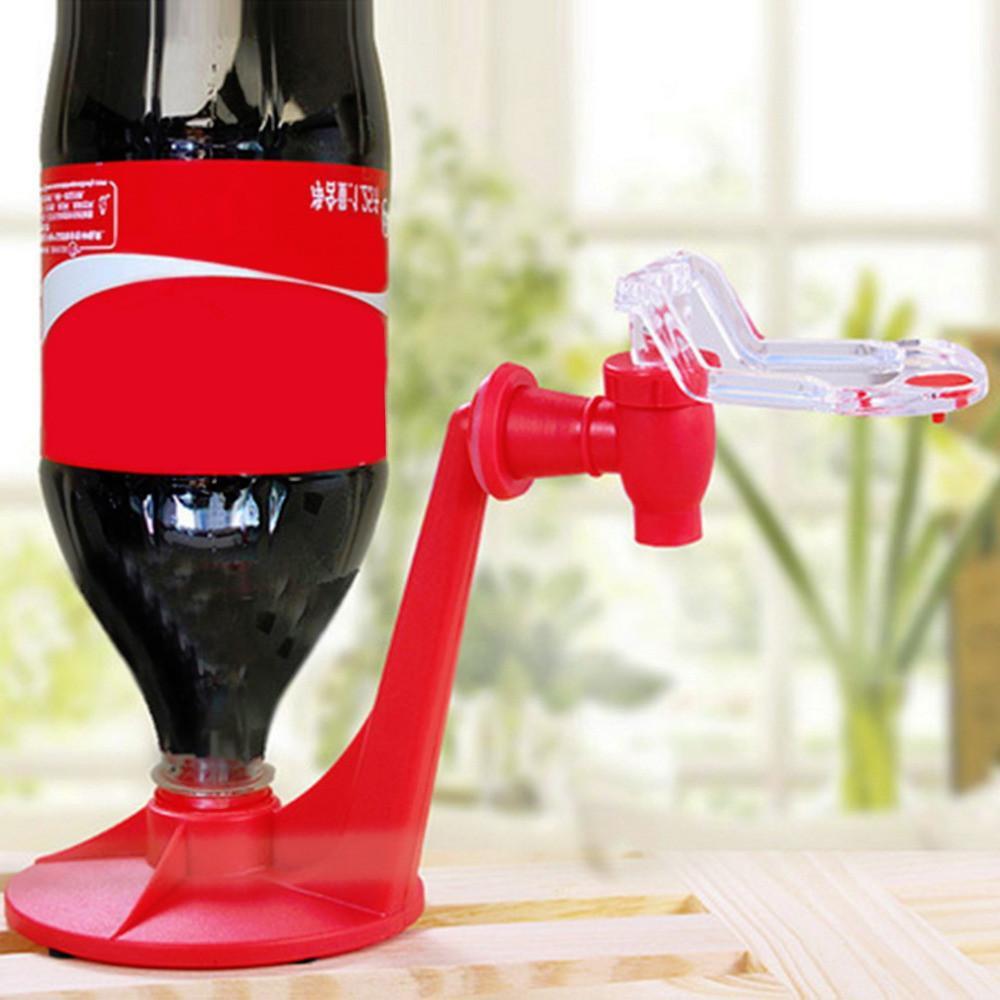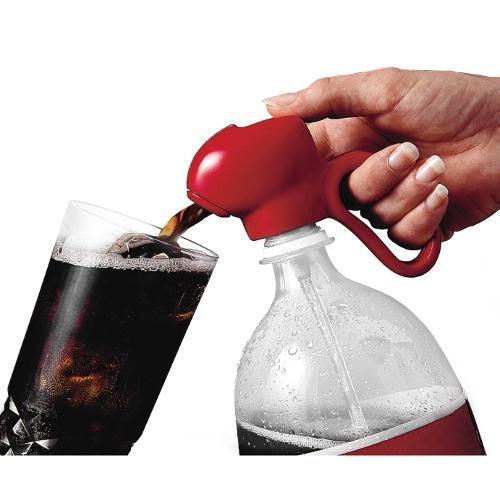The first image is the image on the left, the second image is the image on the right. Evaluate the accuracy of this statement regarding the images: "A person is holding a knife to a bottle in the image on the right.". Is it true? Answer yes or no. No. The first image is the image on the left, the second image is the image on the right. Analyze the images presented: Is the assertion "The right image shows a knife slicing through a bottle on its side, and the left image includes an upright bottle of cola." valid? Answer yes or no. No. 